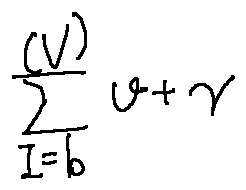Convert formula to latex. <formula><loc_0><loc_0><loc_500><loc_500>\sum \lim i t s _ { I = b } ^ { ( V ) } v + \gamma</formula> 